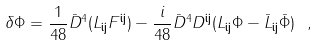Convert formula to latex. <formula><loc_0><loc_0><loc_500><loc_500>\delta \Phi = \frac { 1 } { 4 8 } { \bar { D } } ^ { 4 } ( L _ { { \mathbf i } { \mathbf j } } F ^ { { \mathbf i } { \mathbf j } } ) - \frac { i } { 4 8 } { \bar { D } } ^ { 4 } D ^ { { \mathbf i } { \mathbf j } } ( L _ { { \mathbf i } { \mathbf j } } \Phi - { \bar { L } } _ { { \mathbf i } { \mathbf j } } { \bar { \Phi } } ) \ ,</formula> 